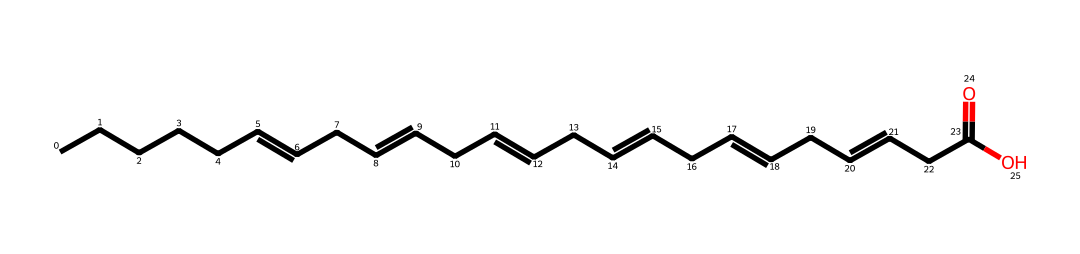What is the functional group present in this molecule? The molecule ends with the -COOH group, which is the carboxylic acid functional group. This indicates that it has acidic properties.
Answer: carboxylic acid How many double bonds are present in the structure? The structure contains three double bonds, which are visually identifiable in the SMILES representation as '=' symbols.
Answer: three What is the total number of carbon atoms in this chemical? By counting the 'C' in the SMILES notation and taking into account the structure of the fatty acid, there are 18 carbon atoms in total.
Answer: eighteen Is this compound saturated or unsaturated? The presence of double bonds in the structure indicates that it is unsaturated, as saturated compounds contain only single bonds.
Answer: unsaturated Which type of fatty acid is represented by this structure? Due to the presence of multiple double bonds and the specific arrangement of carbon chains, this structure represents an omega-3 fatty acid.
Answer: omega-3 How many hydrogen atoms are connected to the carbon chain assuming every carbon forms four bonds? Each carbon typically forms four bonds. By calculating using the number of carbon atoms and considering the double bonds, there are 34 hydrogen atoms connected to the carbon chain.
Answer: thirty-four 